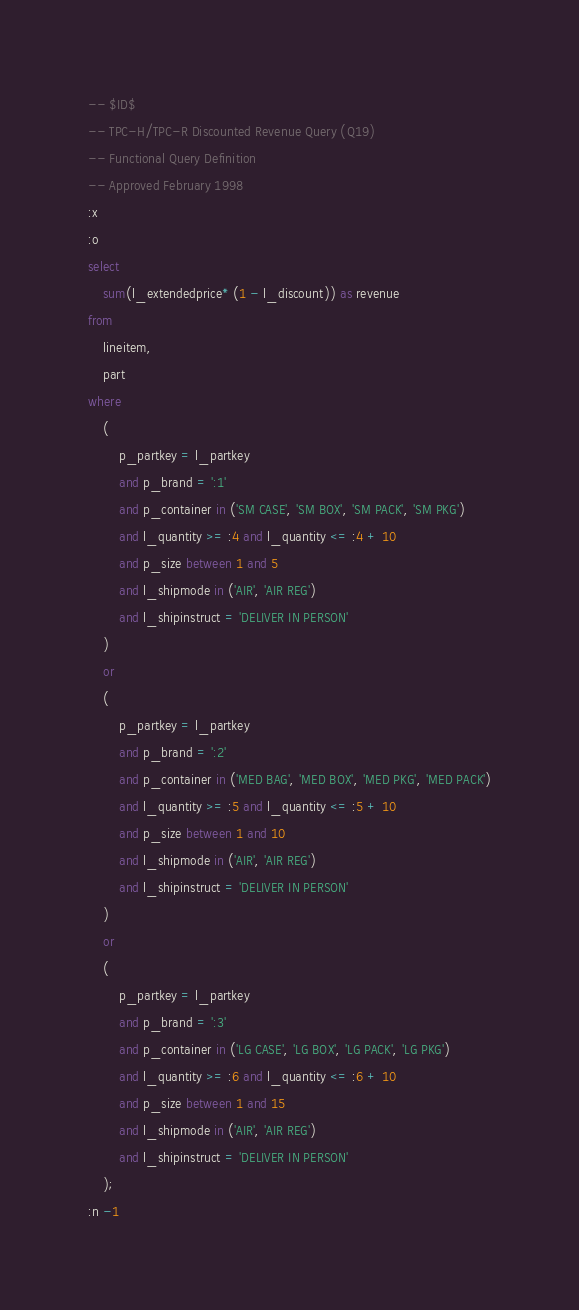<code> <loc_0><loc_0><loc_500><loc_500><_SQL_>-- $ID$
-- TPC-H/TPC-R Discounted Revenue Query (Q19)
-- Functional Query Definition
-- Approved February 1998
:x
:o
select
	sum(l_extendedprice* (1 - l_discount)) as revenue
from
	lineitem,
	part
where
	(
		p_partkey = l_partkey
		and p_brand = ':1'
		and p_container in ('SM CASE', 'SM BOX', 'SM PACK', 'SM PKG')
		and l_quantity >= :4 and l_quantity <= :4 + 10
		and p_size between 1 and 5
		and l_shipmode in ('AIR', 'AIR REG')
		and l_shipinstruct = 'DELIVER IN PERSON'
	)
	or
	(
		p_partkey = l_partkey
		and p_brand = ':2'
		and p_container in ('MED BAG', 'MED BOX', 'MED PKG', 'MED PACK')
		and l_quantity >= :5 and l_quantity <= :5 + 10
		and p_size between 1 and 10
		and l_shipmode in ('AIR', 'AIR REG')
		and l_shipinstruct = 'DELIVER IN PERSON'
	)
	or
	(
		p_partkey = l_partkey
		and p_brand = ':3'
		and p_container in ('LG CASE', 'LG BOX', 'LG PACK', 'LG PKG')
		and l_quantity >= :6 and l_quantity <= :6 + 10
		and p_size between 1 and 15
		and l_shipmode in ('AIR', 'AIR REG')
		and l_shipinstruct = 'DELIVER IN PERSON'
	);
:n -1
</code> 